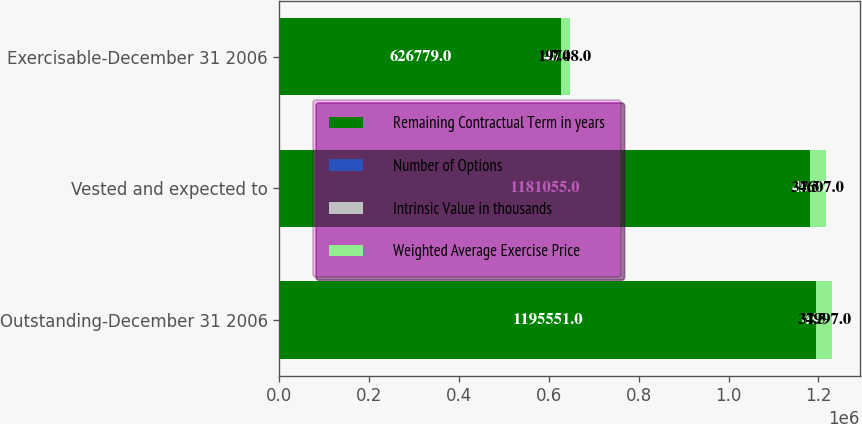Convert chart to OTSL. <chart><loc_0><loc_0><loc_500><loc_500><stacked_bar_chart><ecel><fcel>Outstanding-December 31 2006<fcel>Vested and expected to<fcel>Exercisable-December 31 2006<nl><fcel>Remaining Contractual Term in years<fcel>1.19555e+06<fcel>1.18106e+06<fcel>626779<nl><fcel>Number of Options<fcel>48.9<fcel>48.87<fcel>46.66<nl><fcel>Intrinsic Value in thousands<fcel>7.5<fcel>7.5<fcel>7<nl><fcel>Weighted Average Exercise Price<fcel>34997<fcel>34607<fcel>19748<nl></chart> 